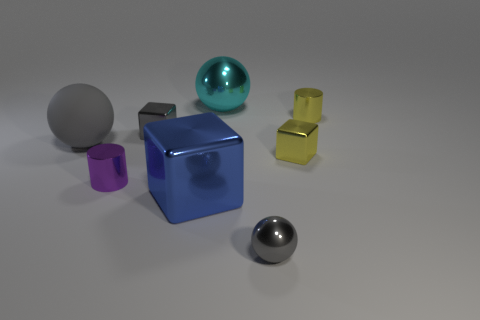There is a purple metal cylinder; how many small yellow things are left of it?
Your answer should be compact. 0. There is a blue object that is the same material as the tiny gray sphere; what is its shape?
Your response must be concise. Cube. Are there fewer big cyan spheres that are on the left side of the cyan metallic thing than blue metal objects on the right side of the big metallic block?
Provide a succinct answer. No. Is the number of large green rubber things greater than the number of large blue metal blocks?
Keep it short and to the point. No. What is the material of the cyan ball?
Make the answer very short. Metal. There is a tiny cylinder that is on the right side of the gray metal ball; what color is it?
Offer a terse response. Yellow. Is the number of tiny cylinders that are to the right of the big blue shiny block greater than the number of yellow metal things that are in front of the cyan object?
Ensure brevity in your answer.  No. There is a gray sphere to the left of the metallic ball in front of the small yellow metallic object that is in front of the big matte object; what is its size?
Keep it short and to the point. Large. Are there any metallic cylinders of the same color as the big block?
Keep it short and to the point. No. What number of large green metal blocks are there?
Give a very brief answer. 0. 